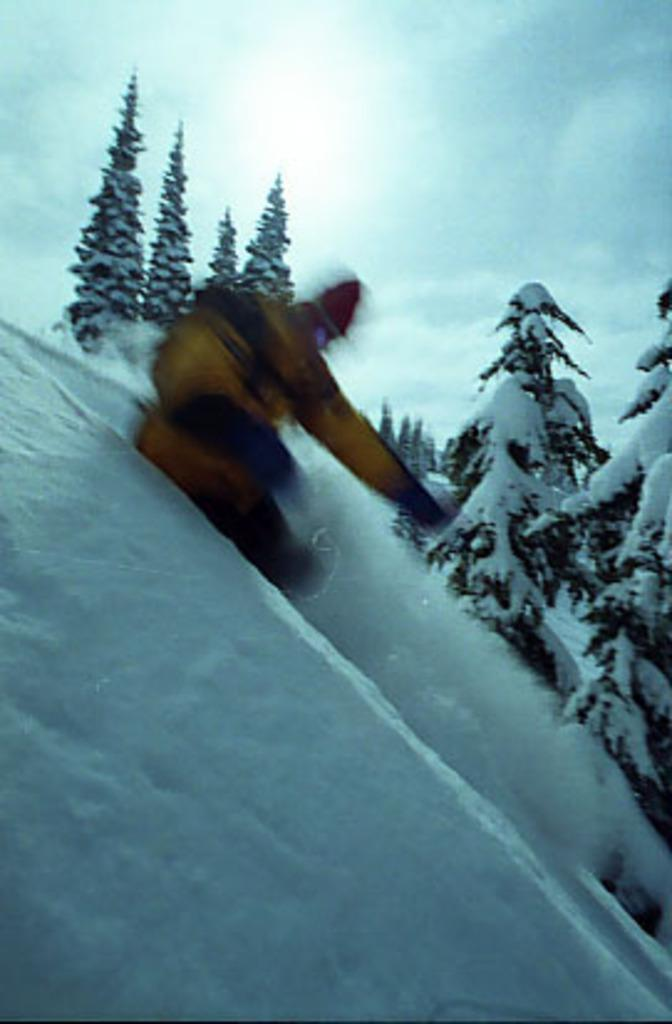Who or what is the main subject in the center of the image? There is a person in the center of the image. What is the surface the person is standing on? The person is standing on snow. What can be seen in the background of the image? There are trees in the background of the image. How are the trees affected by the weather conditions? The trees are covered with snow. What plot of land does the person own in the image? There is no information about the person owning land in the image. What time of day is it in the image? The provided facts do not mention the time of day, so it cannot be determined from the image. 